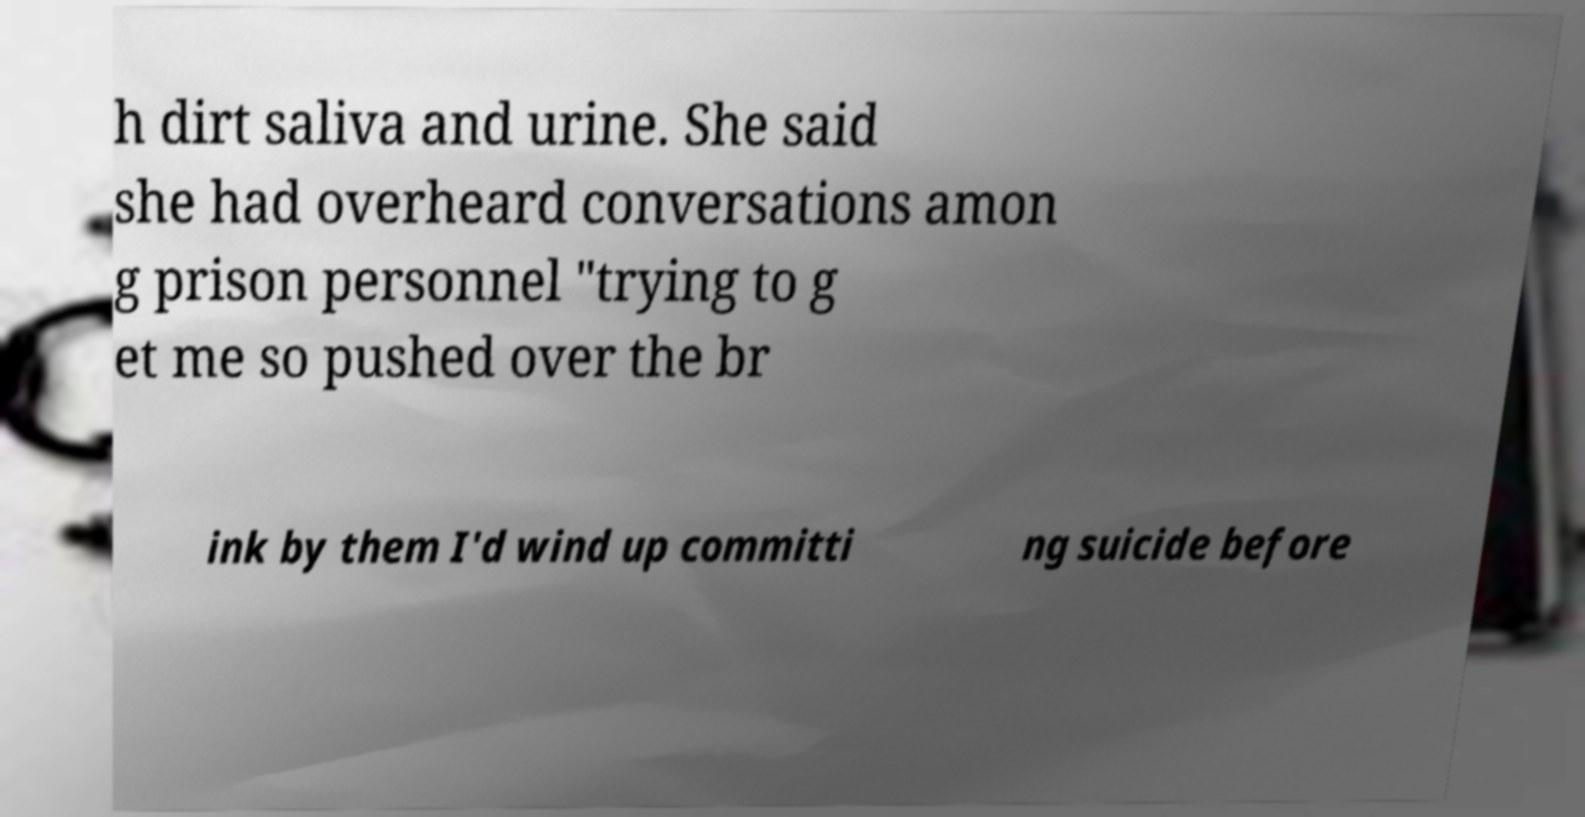Could you assist in decoding the text presented in this image and type it out clearly? h dirt saliva and urine. She said she had overheard conversations amon g prison personnel "trying to g et me so pushed over the br ink by them I'd wind up committi ng suicide before 